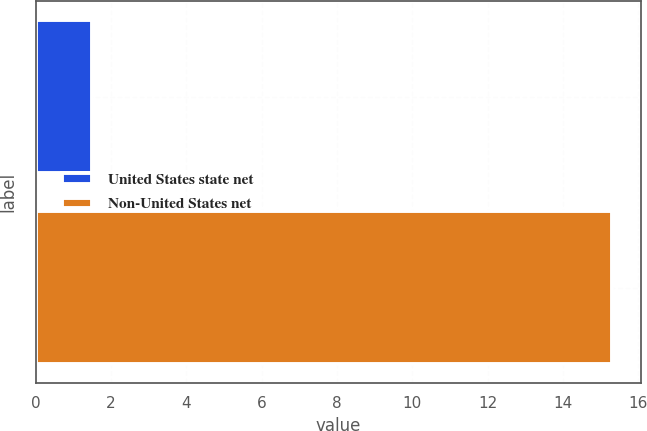<chart> <loc_0><loc_0><loc_500><loc_500><bar_chart><fcel>United States state net<fcel>Non-United States net<nl><fcel>1.5<fcel>15.3<nl></chart> 